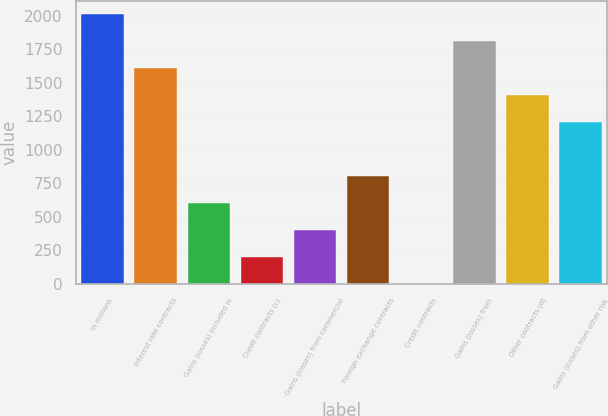<chart> <loc_0><loc_0><loc_500><loc_500><bar_chart><fcel>In millions<fcel>Interest rate contracts<fcel>Gains (losses) included in<fcel>Credit contracts (c)<fcel>Gains (losses) from commercial<fcel>Foreign exchange contracts<fcel>Credit contracts<fcel>Gains (losses) from<fcel>Other contracts (d)<fcel>Gains (losses) from other risk<nl><fcel>2013<fcel>1610.6<fcel>604.6<fcel>202.2<fcel>403.4<fcel>805.8<fcel>1<fcel>1811.8<fcel>1409.4<fcel>1208.2<nl></chart> 